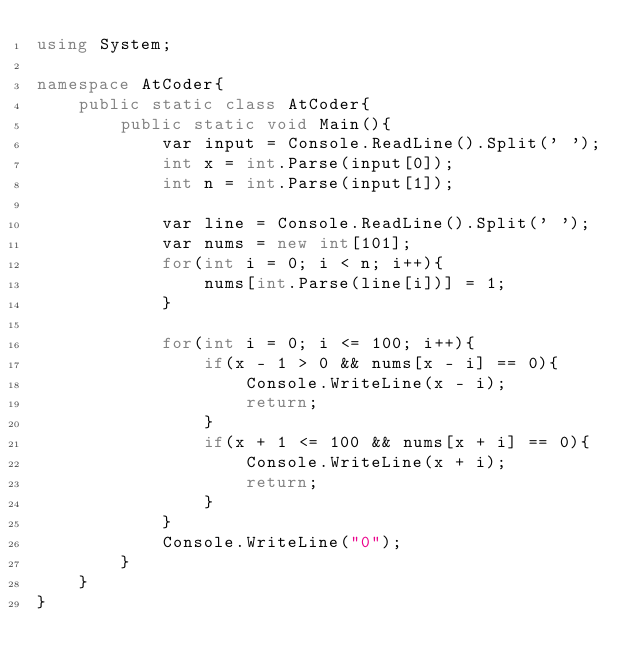<code> <loc_0><loc_0><loc_500><loc_500><_C#_>using System;

namespace AtCoder{
    public static class AtCoder{
        public static void Main(){
            var input = Console.ReadLine().Split(' ');
            int x = int.Parse(input[0]);
            int n = int.Parse(input[1]);

            var line = Console.ReadLine().Split(' ');
            var nums = new int[101];
            for(int i = 0; i < n; i++){
                nums[int.Parse(line[i])] = 1;
            }

            for(int i = 0; i <= 100; i++){
                if(x - 1 > 0 && nums[x - i] == 0){
                    Console.WriteLine(x - i);
                    return;
                }
                if(x + 1 <= 100 && nums[x + i] == 0){
                    Console.WriteLine(x + i);
                    return;
                }
            }
            Console.WriteLine("0");
        }
    }
}</code> 